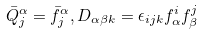<formula> <loc_0><loc_0><loc_500><loc_500>\bar { Q } _ { j } ^ { \alpha } = \bar { f } _ { j } ^ { \alpha } , D _ { \alpha \beta k } = \epsilon _ { i j k } f _ { \alpha } ^ { i } f _ { \beta } ^ { j }</formula> 